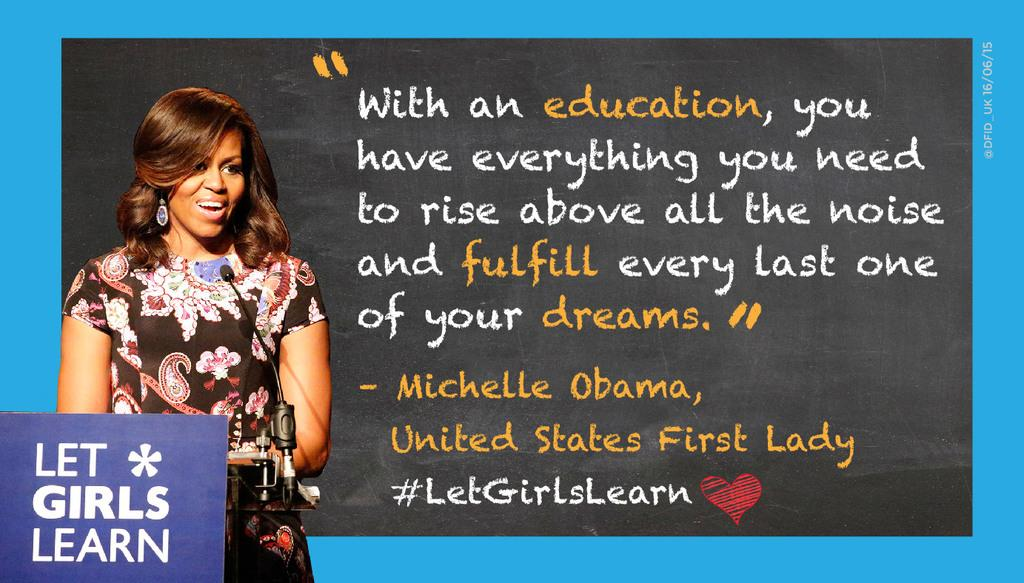What is the woman doing in the image? The woman is standing at a mic on the left side of the image. What can be seen on the right side of the image? There is text on the right side of the image. What type of branch is the woman holding in the image? There is no branch present in the image; the woman is standing at a mic. 